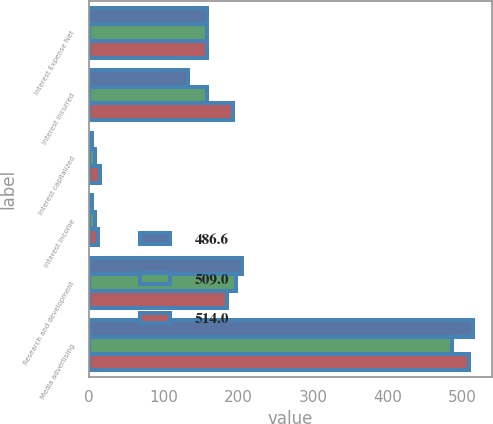Convert chart to OTSL. <chart><loc_0><loc_0><loc_500><loc_500><stacked_bar_chart><ecel><fcel>Interest Expense Net<fcel>Interest incurred<fcel>Interest capitalized<fcel>Interest income<fcel>Research and development<fcel>Media advertising<nl><fcel>486.6<fcel>158.2<fcel>132.1<fcel>4<fcel>4<fcel>204.8<fcel>514<nl><fcel>509<fcel>158.2<fcel>158.2<fcel>7.4<fcel>8<fcel>196.6<fcel>486.6<nl><fcel>514<fcel>158.2<fcel>192.4<fcel>14.4<fcel>11.9<fcel>184.9<fcel>509<nl></chart> 